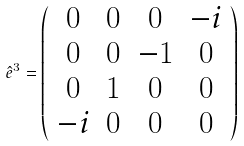<formula> <loc_0><loc_0><loc_500><loc_500>\hat { e } ^ { 3 } = \left ( \begin{array} { c c c c } 0 & 0 & 0 & - i \\ 0 & 0 & - 1 & 0 \\ 0 & 1 & 0 & 0 \\ - i & 0 & 0 & 0 \end{array} \right )</formula> 